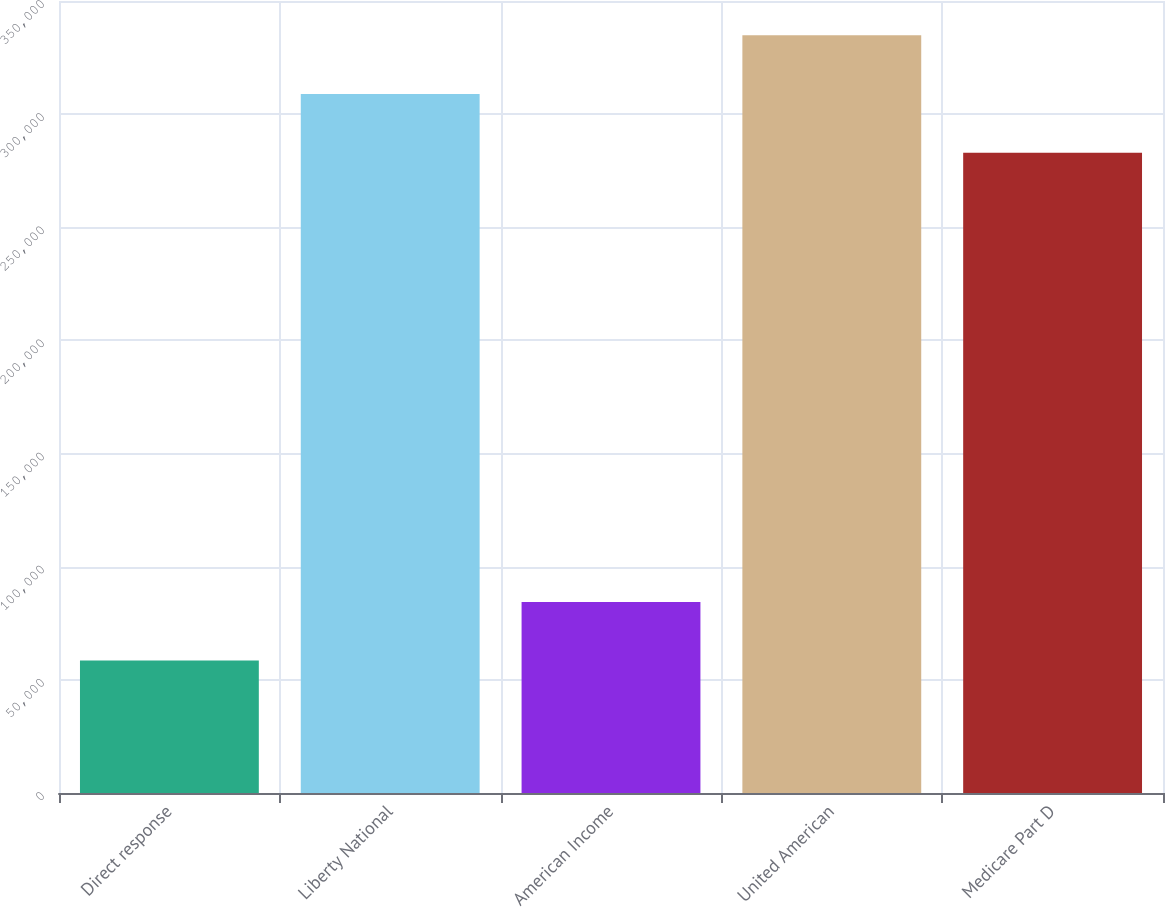Convert chart. <chart><loc_0><loc_0><loc_500><loc_500><bar_chart><fcel>Direct response<fcel>Liberty National<fcel>American Income<fcel>United American<fcel>Medicare Part D<nl><fcel>58512<fcel>308906<fcel>84430.7<fcel>334824<fcel>282987<nl></chart> 